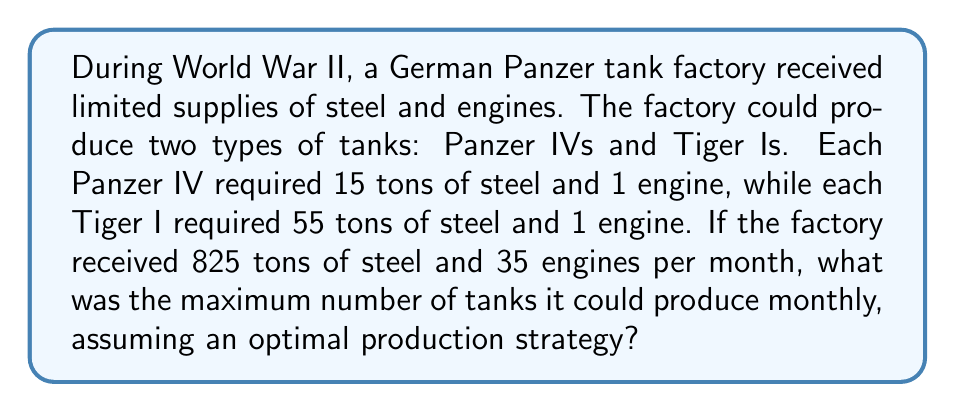Solve this math problem. Let's approach this step-by-step using linear programming:

1) Define variables:
   Let $x$ = number of Panzer IVs
   Let $y$ = number of Tiger Is

2) Set up constraints:
   Steel constraint: $15x + 55y \leq 825$
   Engine constraint: $x + y \leq 35$
   Non-negativity: $x \geq 0, y \geq 0$

3) Objective function:
   Maximize $z = x + y$ (total number of tanks)

4) Solve graphically or algebraically:
   From the engine constraint: $y = 35 - x$
   Substitute into steel constraint:
   $15x + 55(35-x) \leq 825$
   $15x + 1925 - 55x \leq 825$
   $-40x \leq -1100$
   $x \geq 27.5$

5) Check corner points:
   (27.5, 7.5) gives 35 tanks
   (35, 0) gives 35 tanks
   (0, 15) gives 15 tanks

6) The optimal solution is 35 tanks, which can be achieved by producing either:
   - 35 Panzer IVs and 0 Tiger Is, or
   - 27.5 Panzer IVs and 7.5 Tiger Is (rounded to 28 and 7 in practice)
Answer: 35 tanks 